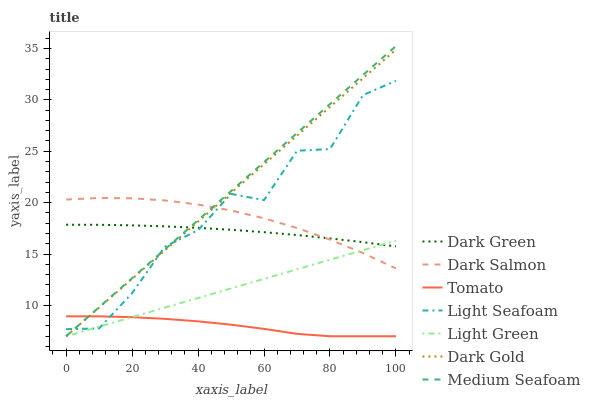Does Tomato have the minimum area under the curve?
Answer yes or no. Yes. Does Medium Seafoam have the maximum area under the curve?
Answer yes or no. Yes. Does Dark Gold have the minimum area under the curve?
Answer yes or no. No. Does Dark Gold have the maximum area under the curve?
Answer yes or no. No. Is Light Green the smoothest?
Answer yes or no. Yes. Is Light Seafoam the roughest?
Answer yes or no. Yes. Is Dark Gold the smoothest?
Answer yes or no. No. Is Dark Gold the roughest?
Answer yes or no. No. Does Tomato have the lowest value?
Answer yes or no. Yes. Does Dark Salmon have the lowest value?
Answer yes or no. No. Does Medium Seafoam have the highest value?
Answer yes or no. Yes. Does Dark Gold have the highest value?
Answer yes or no. No. Is Tomato less than Dark Green?
Answer yes or no. Yes. Is Dark Salmon greater than Tomato?
Answer yes or no. Yes. Does Light Seafoam intersect Dark Green?
Answer yes or no. Yes. Is Light Seafoam less than Dark Green?
Answer yes or no. No. Is Light Seafoam greater than Dark Green?
Answer yes or no. No. Does Tomato intersect Dark Green?
Answer yes or no. No. 